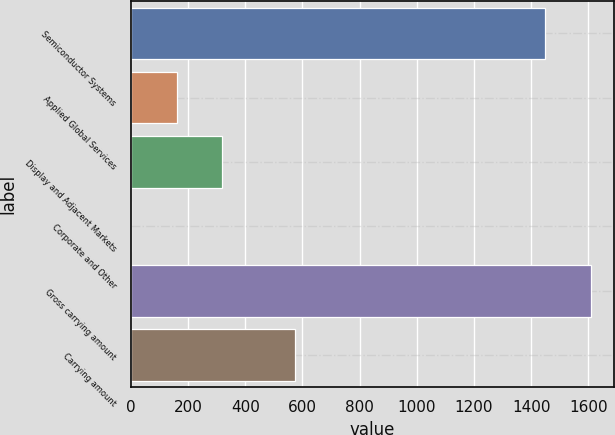Convert chart. <chart><loc_0><loc_0><loc_500><loc_500><bar_chart><fcel>Semiconductor Systems<fcel>Applied Global Services<fcel>Display and Adjacent Markets<fcel>Corporate and Other<fcel>Gross carrying amount<fcel>Carrying amount<nl><fcel>1449<fcel>160<fcel>319<fcel>1<fcel>1608<fcel>575<nl></chart> 